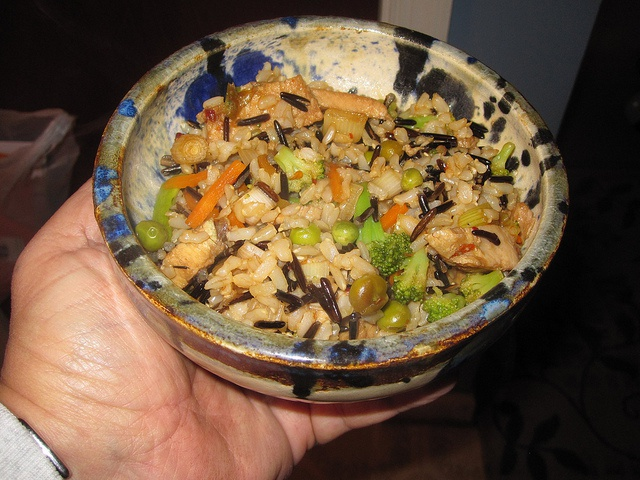Describe the objects in this image and their specific colors. I can see bowl in black, tan, and olive tones, people in black, tan, and salmon tones, broccoli in black and olive tones, broccoli in black, olive, tan, and khaki tones, and broccoli in black and olive tones in this image. 